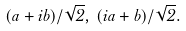<formula> <loc_0><loc_0><loc_500><loc_500>( a + i b ) / \sqrt { 2 } , \, ( i a + b ) / \sqrt { 2 } .</formula> 